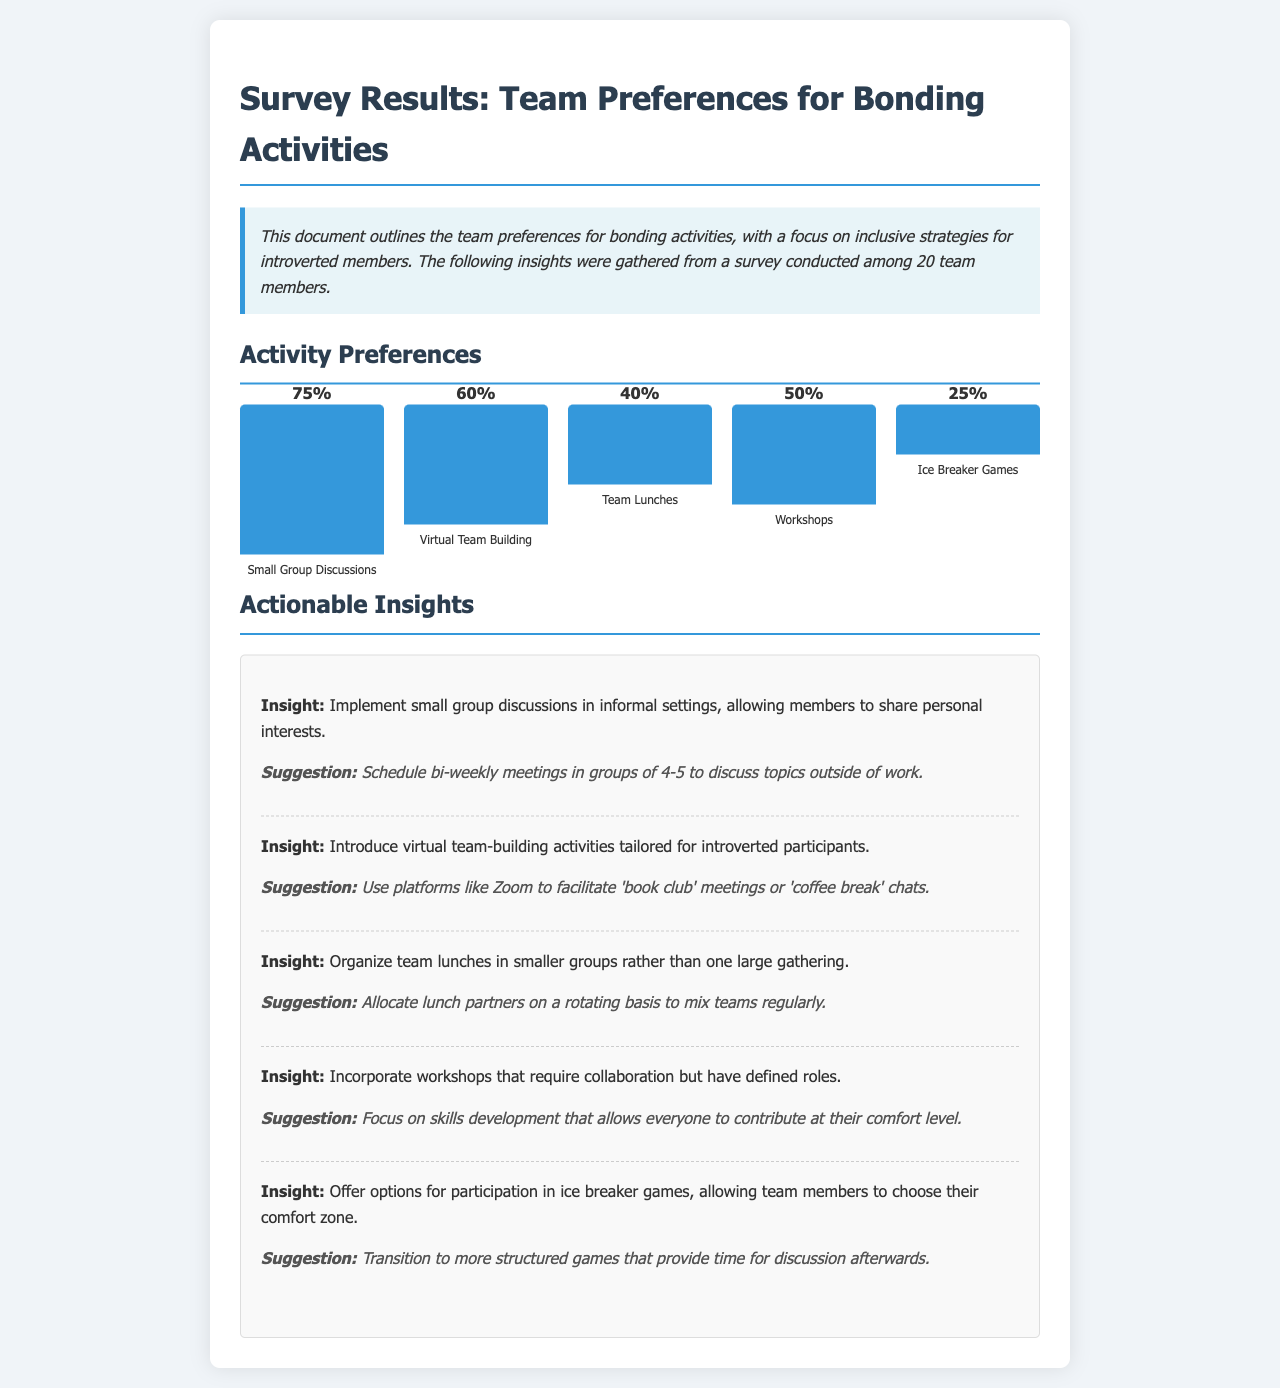What percentage of respondents prefer small group discussions? The response shows that 75% of team members prefer small group discussions as a bonding activity.
Answer: 75% What is the height of the bar representing virtual team building? The visual representation indicates that the bar for virtual team building has a height of 120 pixels, corresponding to a preference of 60%.
Answer: 120px How many team members participated in the survey? The summary states that the survey was conducted among 20 team members.
Answer: 20 What insight suggests implementing small group discussions? The document describes an insight that emphasizes implementing small group discussions in informal settings.
Answer: Small group discussions What suggestion is made for virtual team building? The document suggests using platforms like Zoom for 'book club' meetings or 'coffee break' chats as a suggestion for virtual team building.
Answer: Use Zoom for 'book club' meetings What percentage of respondents prefer ice breaker games? The survey results show that 25% of respondents prefer ice breaker games as a bonding activity.
Answer: 25% What is recommended for organizing team lunches? Organizing team lunches in smaller groups is recommended in the insights section of the document.
Answer: Smaller groups In what frequency are small group discussions suggested to be scheduled? The suggestion states that small group discussions should be scheduled bi-weekly.
Answer: Bi-weekly Which activity has the lowest percentage preference? Ice breaker games have the lowest preference at 25%.
Answer: Ice breaker games 